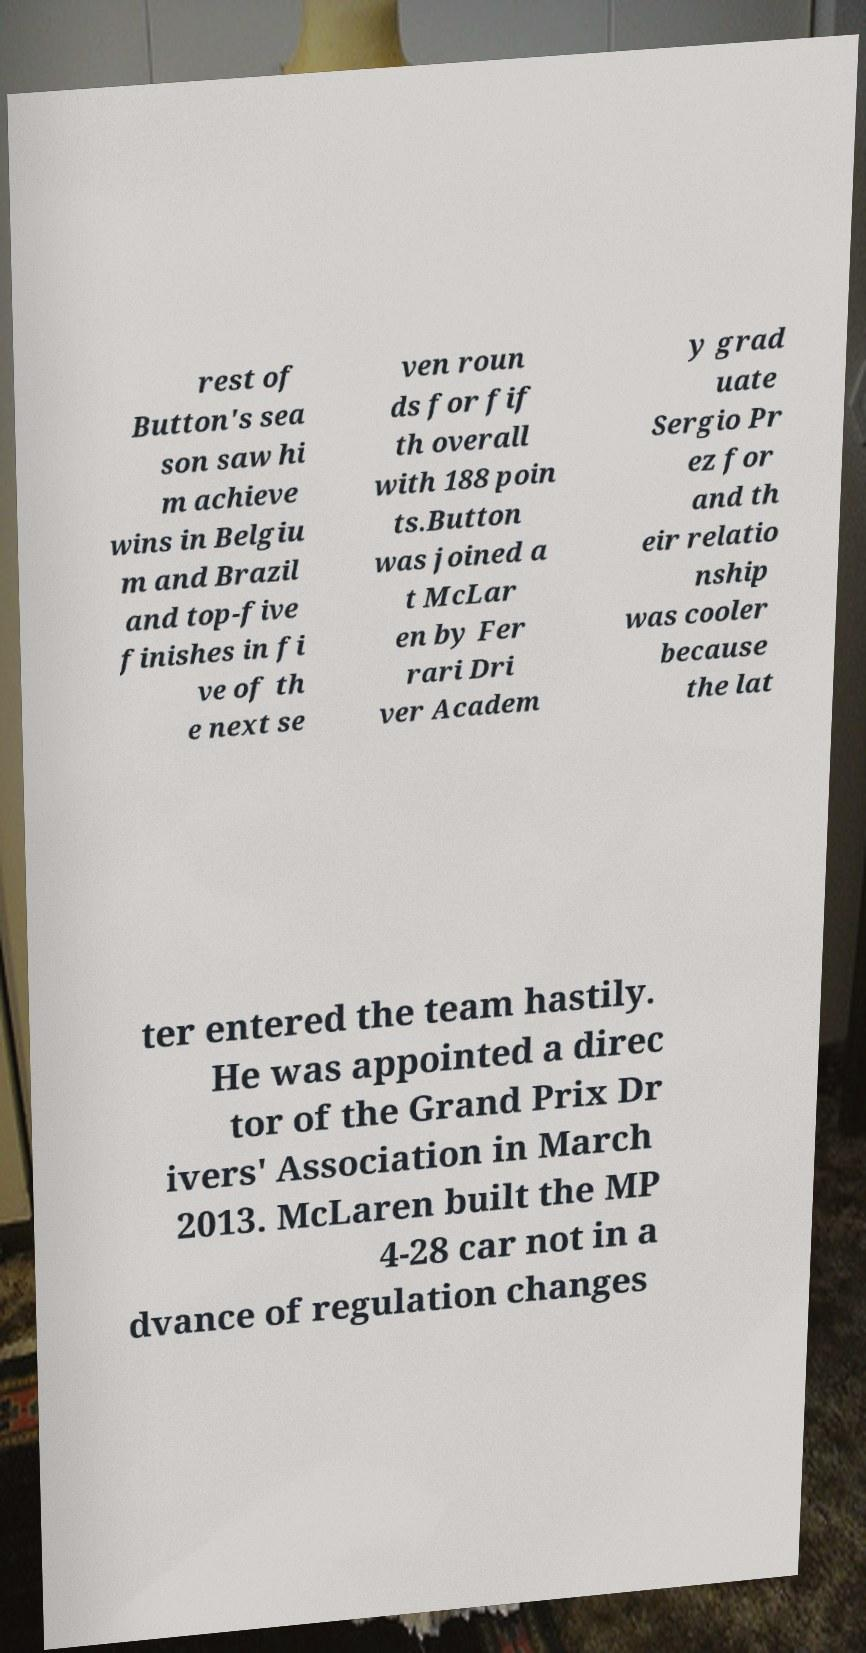For documentation purposes, I need the text within this image transcribed. Could you provide that? rest of Button's sea son saw hi m achieve wins in Belgiu m and Brazil and top-five finishes in fi ve of th e next se ven roun ds for fif th overall with 188 poin ts.Button was joined a t McLar en by Fer rari Dri ver Academ y grad uate Sergio Pr ez for and th eir relatio nship was cooler because the lat ter entered the team hastily. He was appointed a direc tor of the Grand Prix Dr ivers' Association in March 2013. McLaren built the MP 4-28 car not in a dvance of regulation changes 